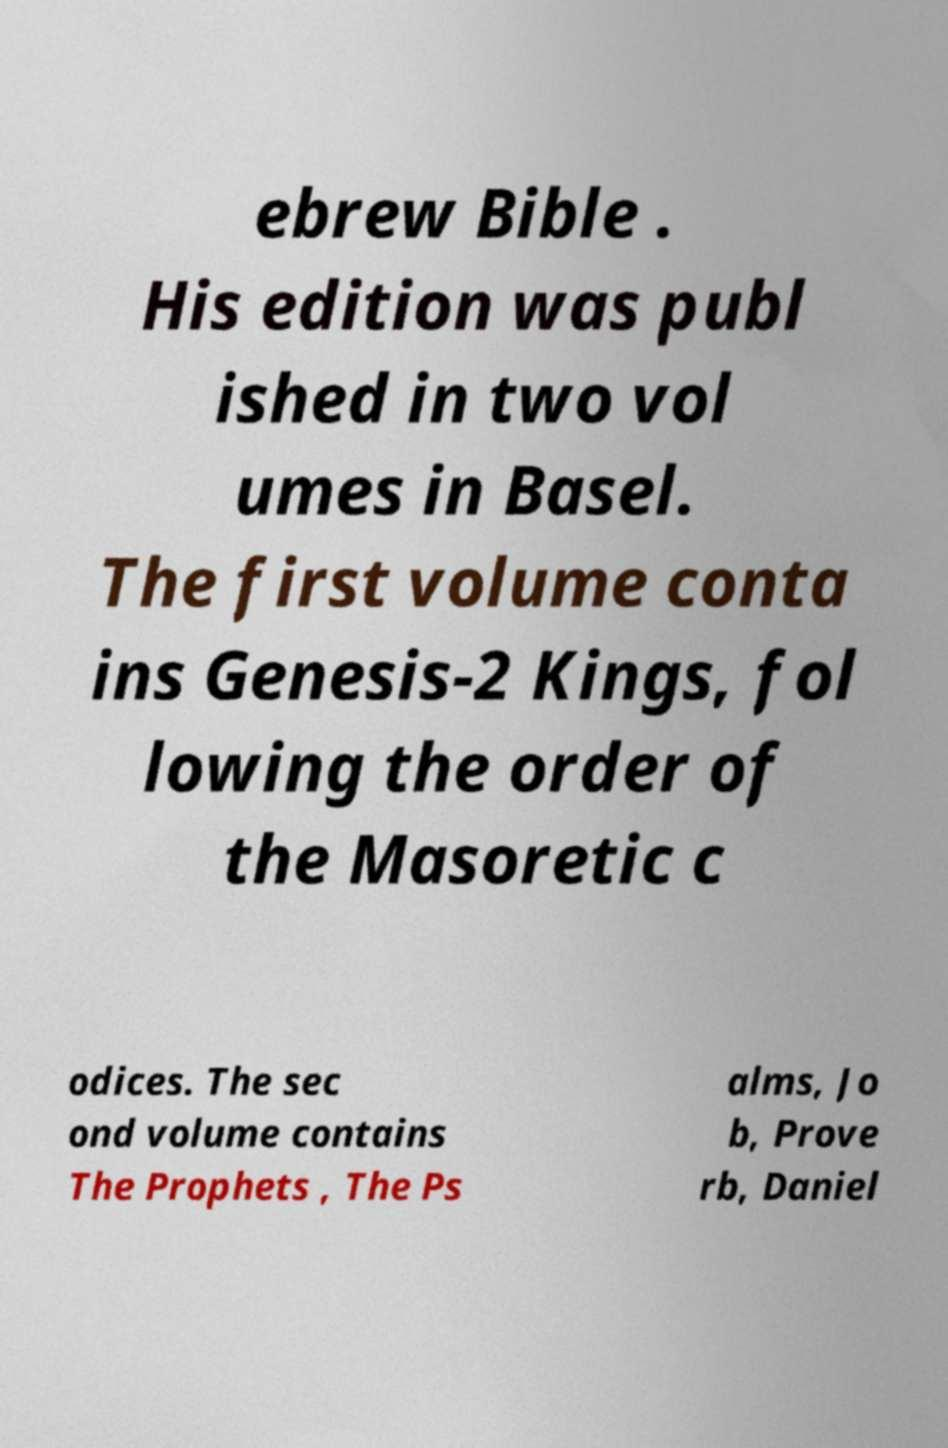What messages or text are displayed in this image? I need them in a readable, typed format. ebrew Bible . His edition was publ ished in two vol umes in Basel. The first volume conta ins Genesis-2 Kings, fol lowing the order of the Masoretic c odices. The sec ond volume contains The Prophets , The Ps alms, Jo b, Prove rb, Daniel 